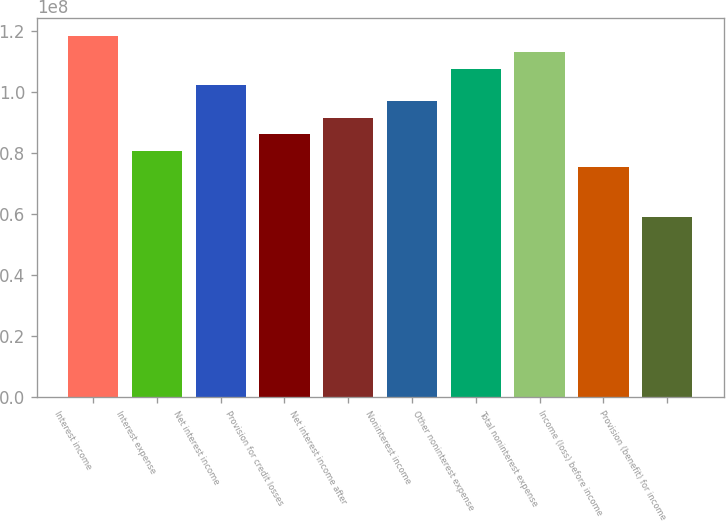<chart> <loc_0><loc_0><loc_500><loc_500><bar_chart><fcel>Interest income<fcel>Interest expense<fcel>Net interest income<fcel>Provision for credit losses<fcel>Net interest income after<fcel>Noninterest income<fcel>Other noninterest expense<fcel>Total noninterest expense<fcel>Income (loss) before income<fcel>Provision (benefit) for income<nl><fcel>1.18403e+08<fcel>8.07295e+07<fcel>1.02257e+08<fcel>8.61114e+07<fcel>9.14934e+07<fcel>9.68754e+07<fcel>1.07639e+08<fcel>1.13021e+08<fcel>7.53475e+07<fcel>5.92016e+07<nl></chart> 